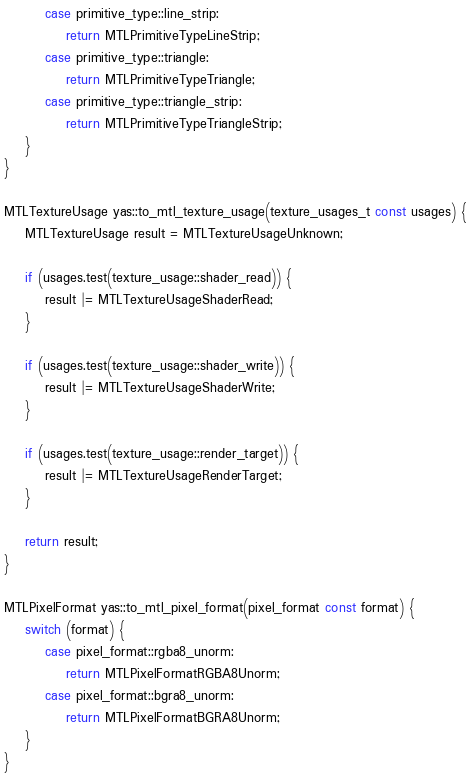Convert code to text. <code><loc_0><loc_0><loc_500><loc_500><_ObjectiveC_>        case primitive_type::line_strip:
            return MTLPrimitiveTypeLineStrip;
        case primitive_type::triangle:
            return MTLPrimitiveTypeTriangle;
        case primitive_type::triangle_strip:
            return MTLPrimitiveTypeTriangleStrip;
    }
}

MTLTextureUsage yas::to_mtl_texture_usage(texture_usages_t const usages) {
    MTLTextureUsage result = MTLTextureUsageUnknown;

    if (usages.test(texture_usage::shader_read)) {
        result |= MTLTextureUsageShaderRead;
    }

    if (usages.test(texture_usage::shader_write)) {
        result |= MTLTextureUsageShaderWrite;
    }

    if (usages.test(texture_usage::render_target)) {
        result |= MTLTextureUsageRenderTarget;
    }

    return result;
}

MTLPixelFormat yas::to_mtl_pixel_format(pixel_format const format) {
    switch (format) {
        case pixel_format::rgba8_unorm:
            return MTLPixelFormatRGBA8Unorm;
        case pixel_format::bgra8_unorm:
            return MTLPixelFormatBGRA8Unorm;
    }
}
</code> 